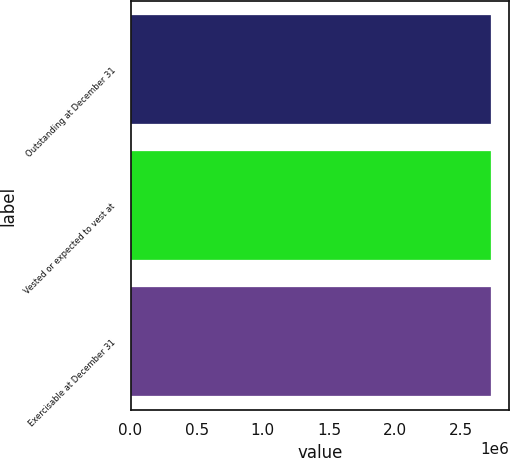Convert chart to OTSL. <chart><loc_0><loc_0><loc_500><loc_500><bar_chart><fcel>Outstanding at December 31<fcel>Vested or expected to vest at<fcel>Exercisable at December 31<nl><fcel>2.7254e+06<fcel>2.7254e+06<fcel>2.7254e+06<nl></chart> 